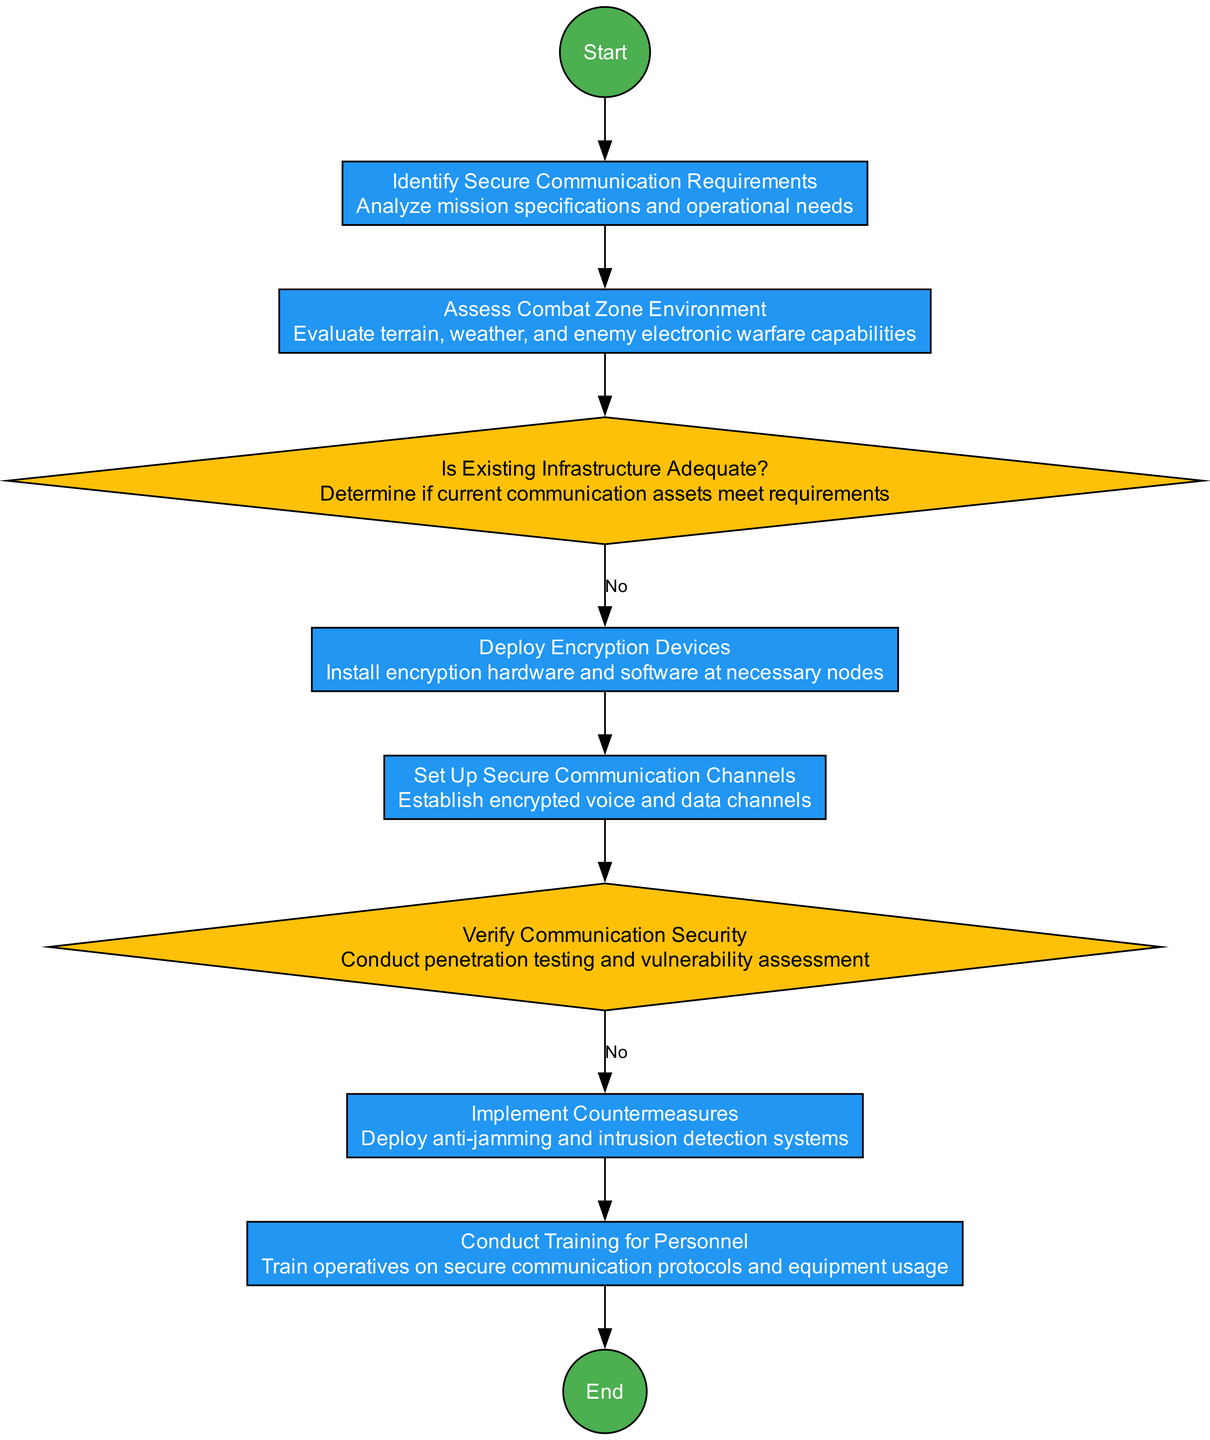What is the first activity in the diagram? The first activity in the diagram is "Identify Secure Communication Requirements". This is determined by checking the order of nodes from the start node, as activities follow the start until the first activity is reached.
Answer: Identify Secure Communication Requirements How many activities are there? Counting the nodes categorized as activities, we find that there are five activities in total: "Identify Secure Communication Requirements", "Deploy Encryption Devices", "Set Up Secure Communication Channels", "Implement Countermeasures", and "Conduct Training for Personnel".
Answer: 5 What decision follows the "Assess Combat Zone Environment" activity? After the "Assess Combat Zone Environment" activity, there is a decision node titled "Is Existing Infrastructure Adequate?". This can be identified by the flow of edges from the activities to the decision nodes.
Answer: Is Existing Infrastructure Adequate? Which node represents a countermeasure implementation step? The node that represents a countermeasure implementation step is "Implement Countermeasures". This is identified by reviewing the activities related to ensuring secure communication after analyzing vulnerabilities.
Answer: Implement Countermeasures What happens if the existing infrastructure is inadequate? If the existing infrastructure is inadequate, the protocol flow appears to redirect back to earlier steps, encouraging either re-evaluation or deployment of new resources, though specifics of what occurs next would have to be considered contextually.
Answer: Deploy Encryption Devices How many decision nodes are present in the diagram? There are two decision nodes visible in the diagram: "Is Existing Infrastructure Adequate?" and "Verify Communication Security". We identify these nodes by looking for diamond shapes specifically labeled as decisions.
Answer: 2 What is the last action before reaching the end of the diagram? The last action before reaching the end of the diagram is "Conduct Training for Personnel". This can be found as we trace through the activities, noting that it is the last activity leading to the end node.
Answer: Conduct Training for Personnel 